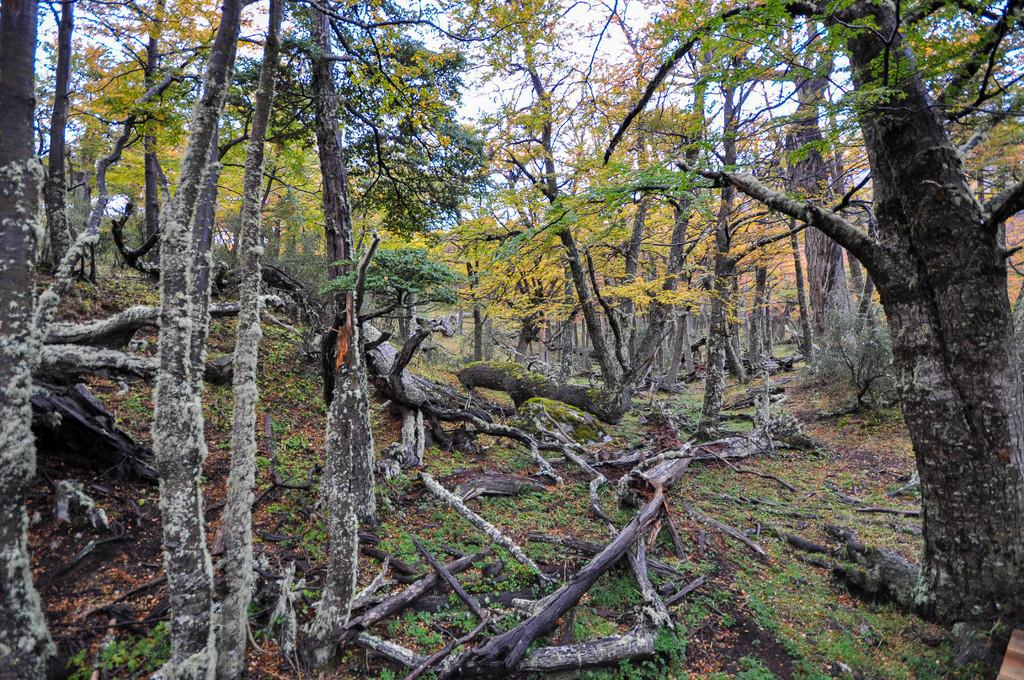What type of vegetation can be seen in the image? There are trees in the image. What part of the trees can be seen on the ground in the image? There are tree barks on the ground in the image. What is the condition of the sky in the image? The sky is cloudy in the image. What type of learning material is visible on the ground in the image? There is no learning material present in the image; it features trees and tree barks on the ground. What type of breakfast food is visible in the image? There is no breakfast food present in the image; it features trees, tree barks, and a cloudy sky. 